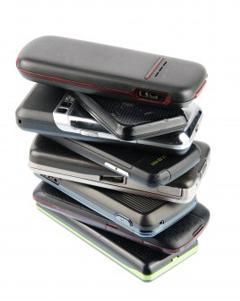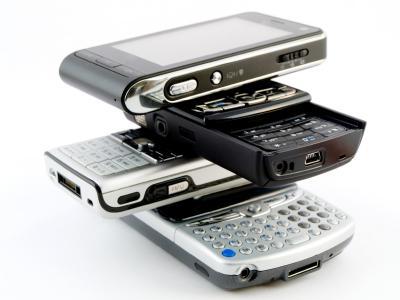The first image is the image on the left, the second image is the image on the right. Evaluate the accuracy of this statement regarding the images: "The right image contains a stack of four phones, with the phones stacked in a staggered fashion instead of aligned.". Is it true? Answer yes or no. Yes. The first image is the image on the left, the second image is the image on the right. Examine the images to the left and right. Is the description "At least four phones are stacked on top of each other in at least one of the pictures." accurate? Answer yes or no. Yes. 